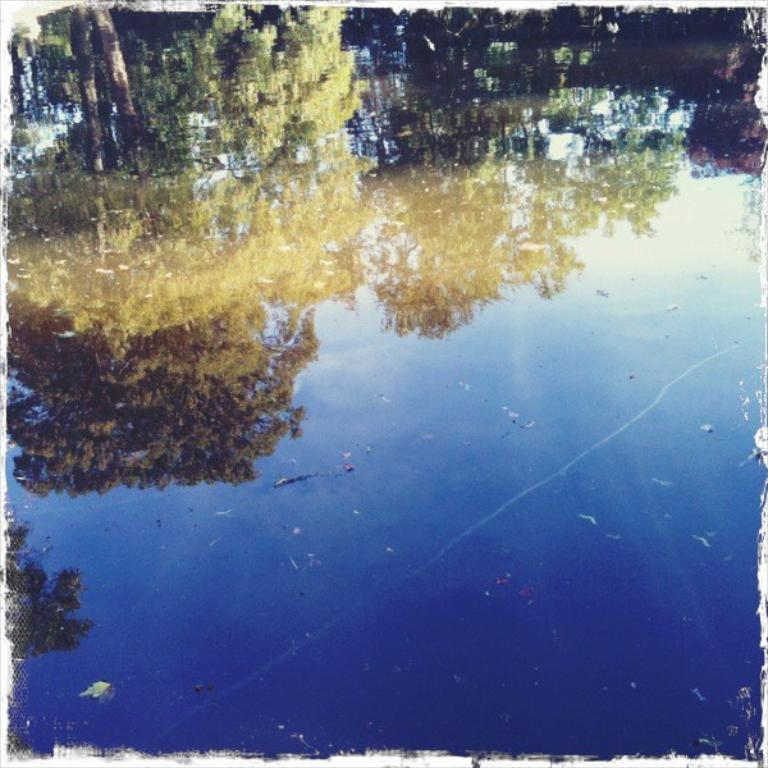What is the main feature of the image? There is a water body in the image. What can be seen in the water? The reflection of trees is visible in the water. How many snails can be seen crawling on the trees in the image? There are no snails visible in the image; it only shows the reflection of trees in the water. What time of day is depicted in the image? The time of day cannot be determined from the image, as there are no specific indicators of time. 